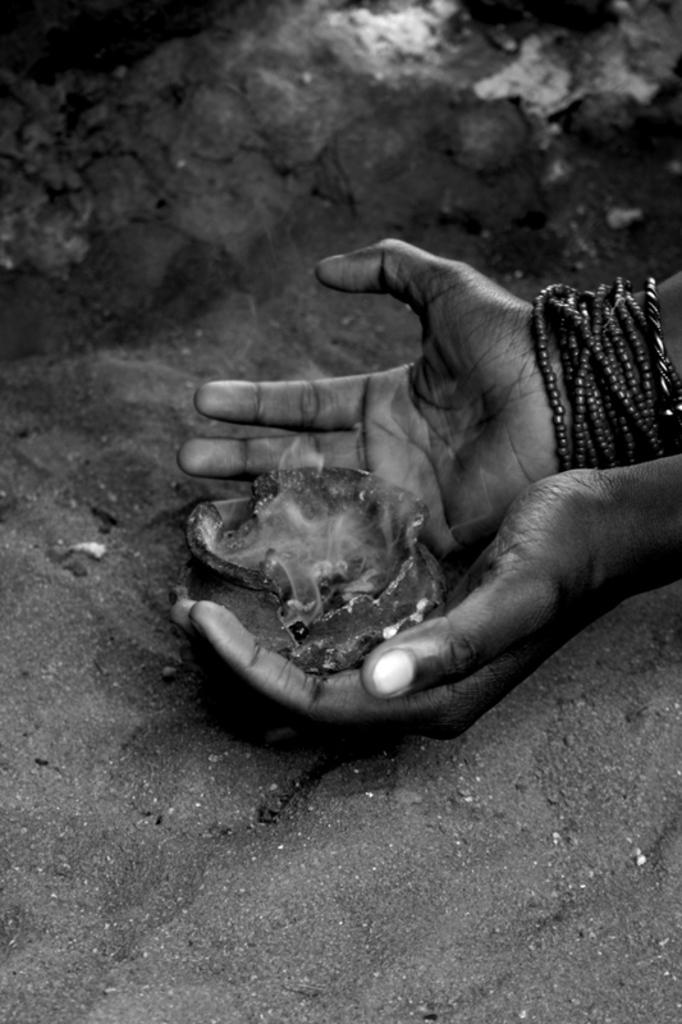What is the main subject of the image? There is a jellyfish in the image. How is the jellyfish being held in the image? The jellyfish is being held by a person, as it is "in the hand." What type of environment can be seen in the background of the image? There is sand visible in the background of the image. What type of haircut does the jellyfish have in the image? There is no haircut present in the image, as jellyfish do not have hair. How many visitors can be seen in the image? There is no visitor present in the image; it only shows a jellyfish being held by a person. 